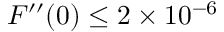Convert formula to latex. <formula><loc_0><loc_0><loc_500><loc_500>F ^ { \prime \prime } ( 0 ) \leq 2 \times 1 0 ^ { - 6 }</formula> 